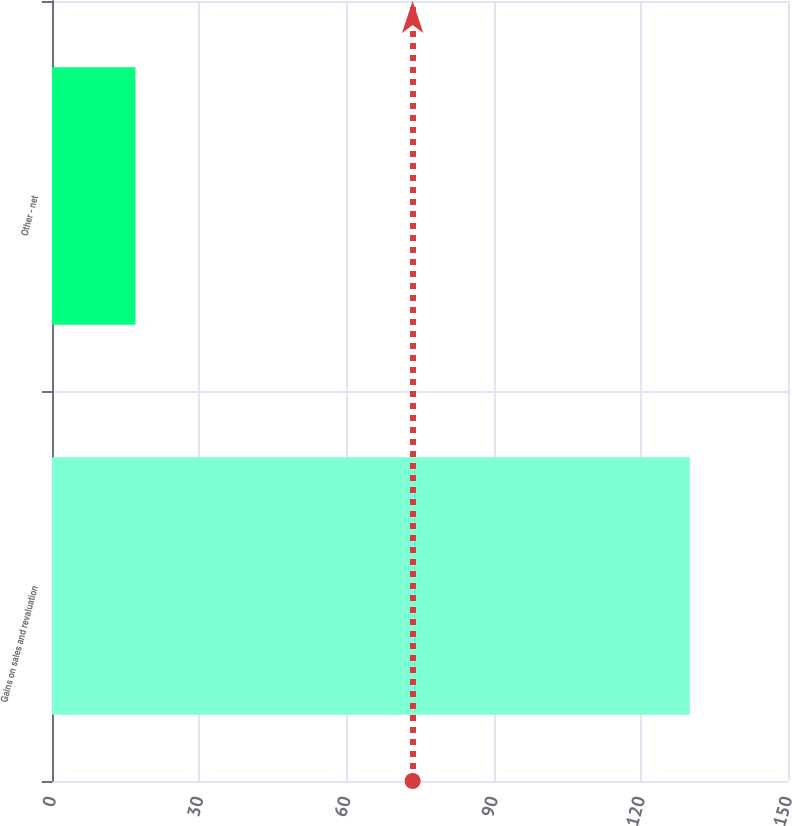Convert chart. <chart><loc_0><loc_0><loc_500><loc_500><bar_chart><fcel>Gains on sales and revaluation<fcel>Other - net<nl><fcel>130<fcel>17<nl></chart> 